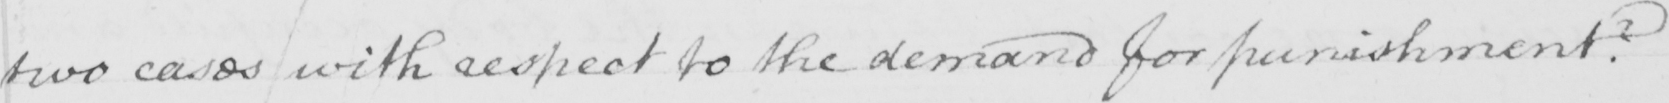Please provide the text content of this handwritten line. two cases with respect to the demand for punishment ? 